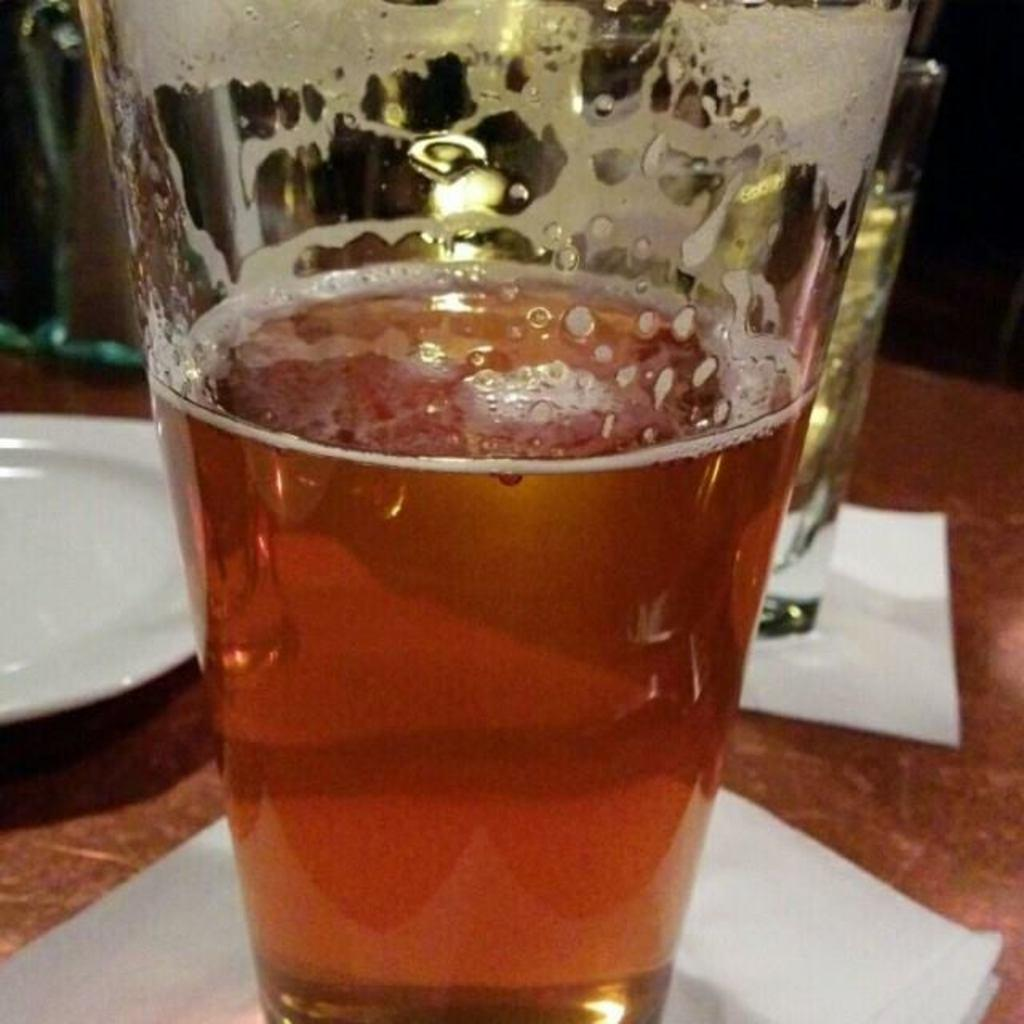What objects in the image contain liquid? There are glasses with liquid in the image. What type of items can be seen on the plate in the image? The provided facts do not mention any specific items on the plate. What else is present in the image besides the glasses and plate? There are papers in the image. What type of nut is being cracked by the hand in the image? There is no hand or nut present in the image. 